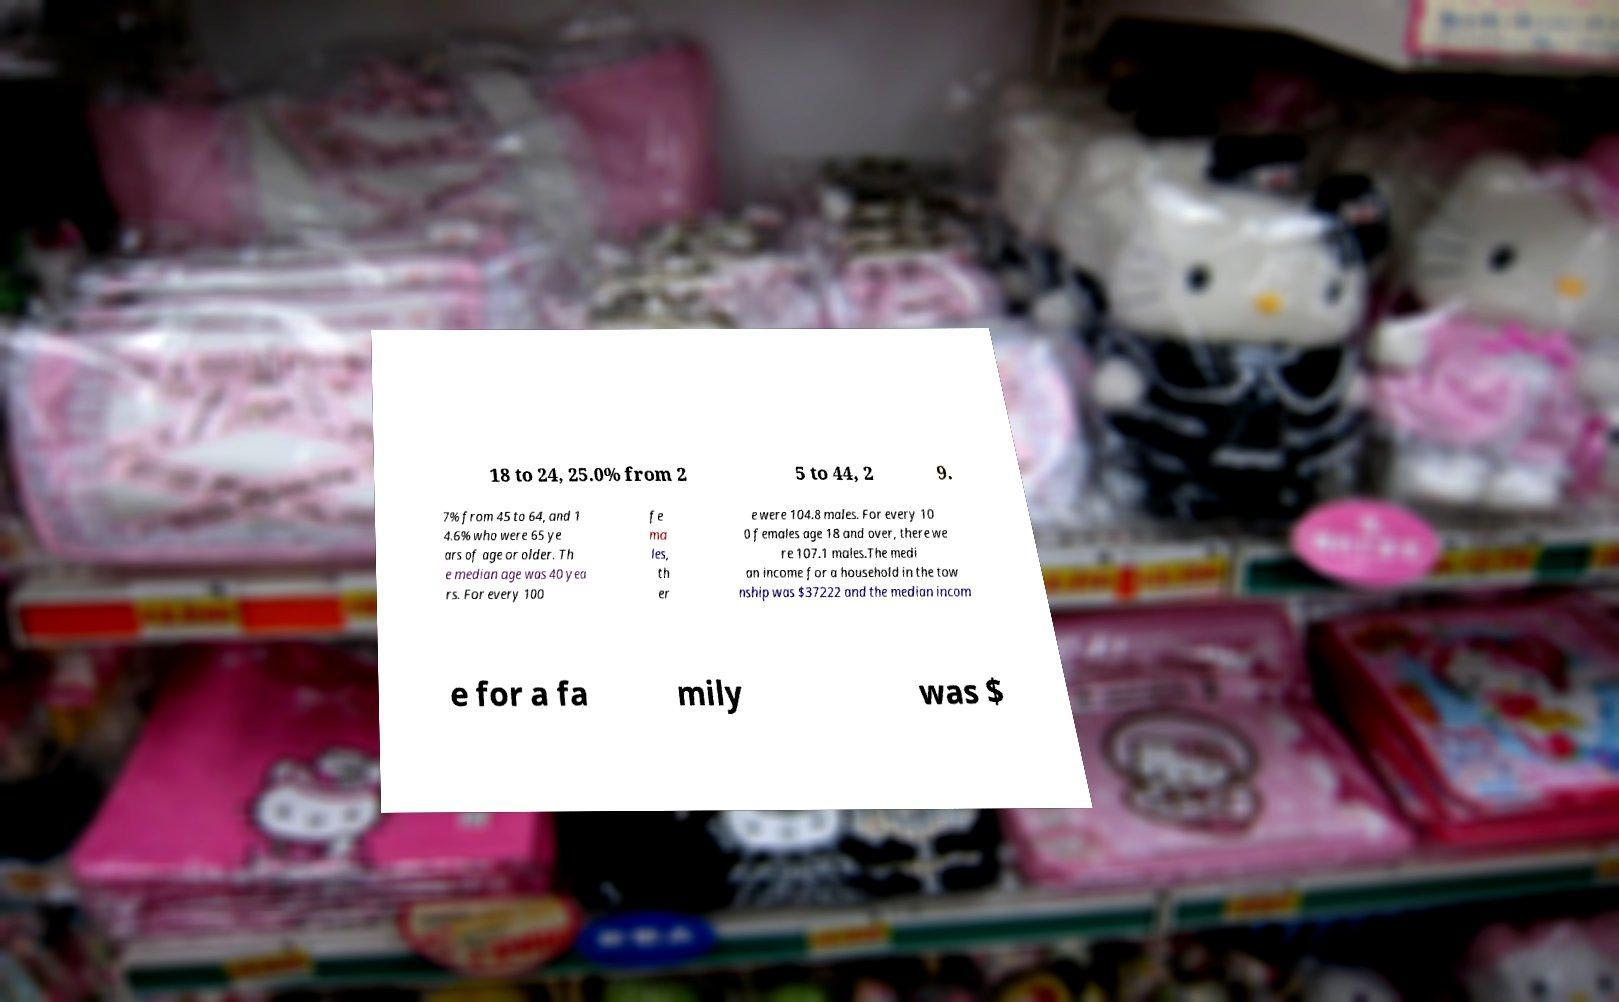Please identify and transcribe the text found in this image. 18 to 24, 25.0% from 2 5 to 44, 2 9. 7% from 45 to 64, and 1 4.6% who were 65 ye ars of age or older. Th e median age was 40 yea rs. For every 100 fe ma les, th er e were 104.8 males. For every 10 0 females age 18 and over, there we re 107.1 males.The medi an income for a household in the tow nship was $37222 and the median incom e for a fa mily was $ 